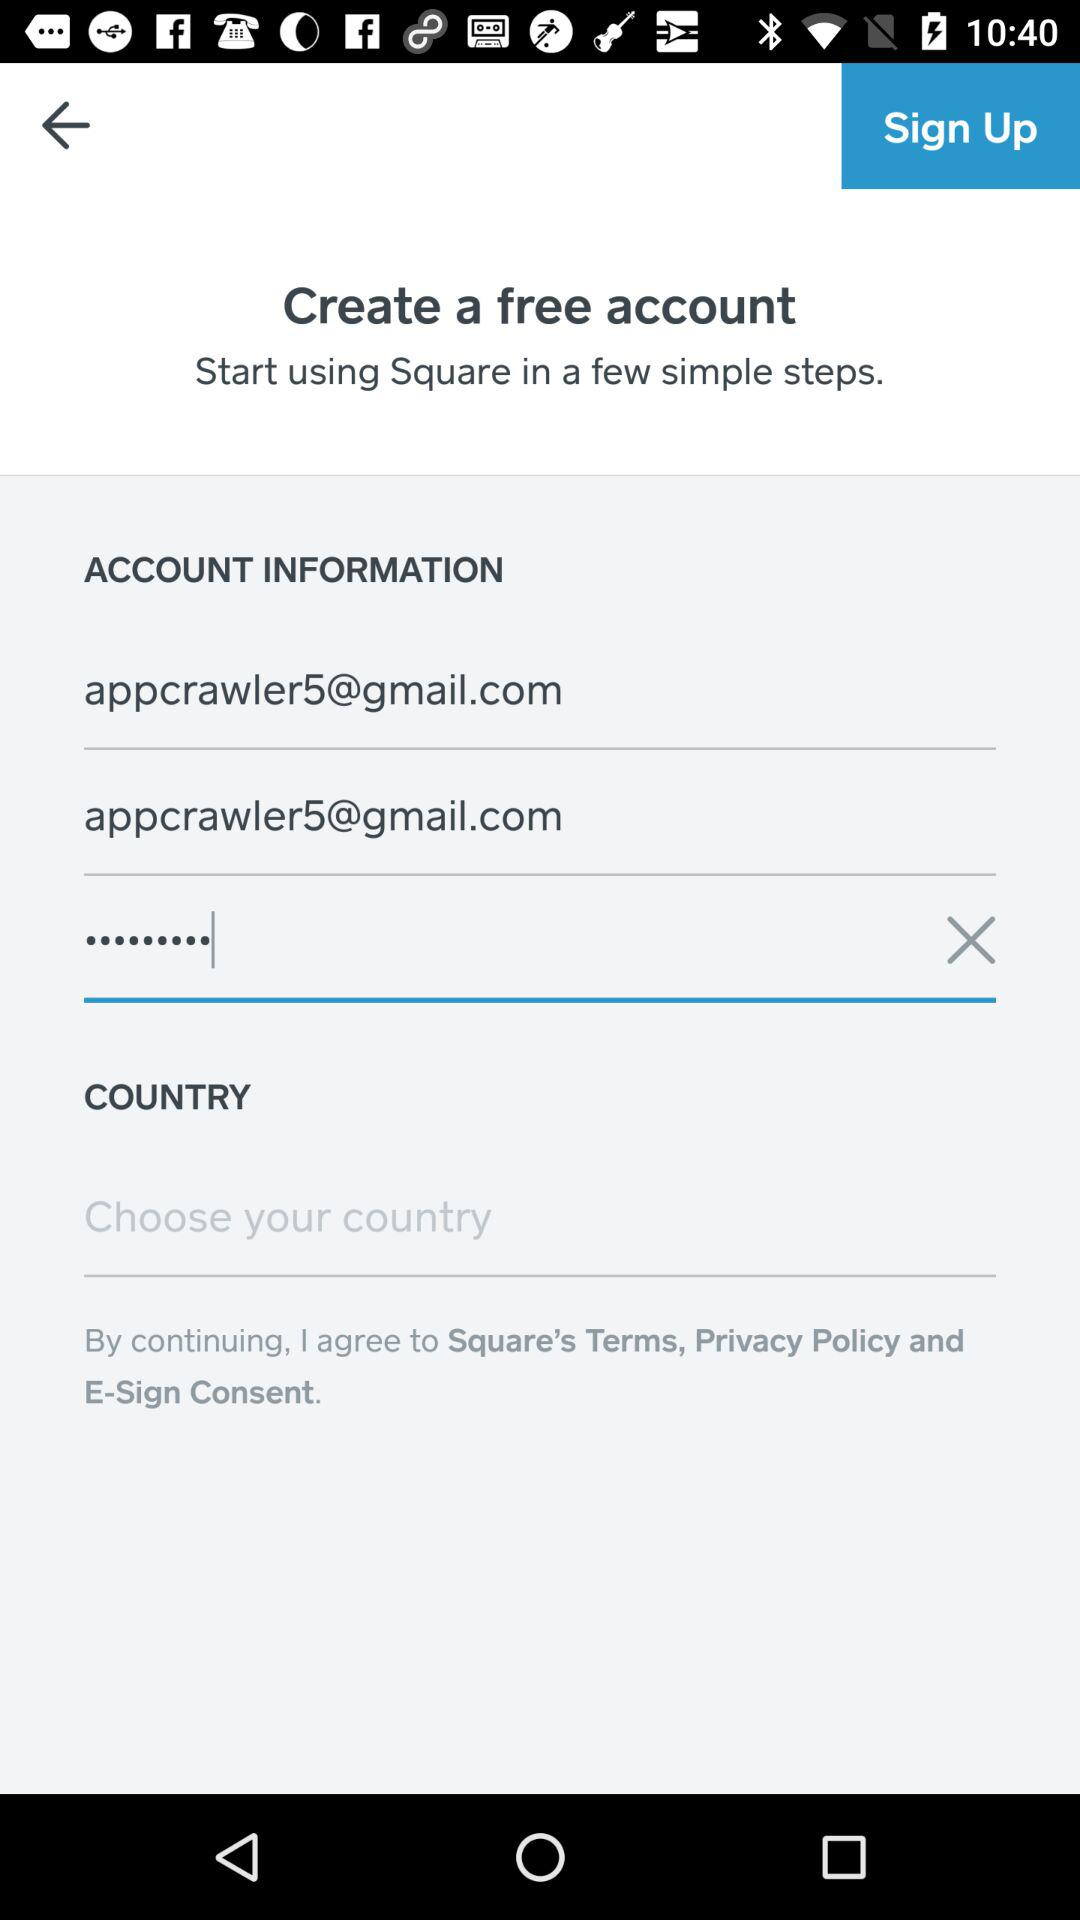How many text inputs are there with an email address in them? In the image provided, there is only one text input field that contains an email address visibly entered into it. The field is labeled with the email address appcrawler5@gmail.com. 